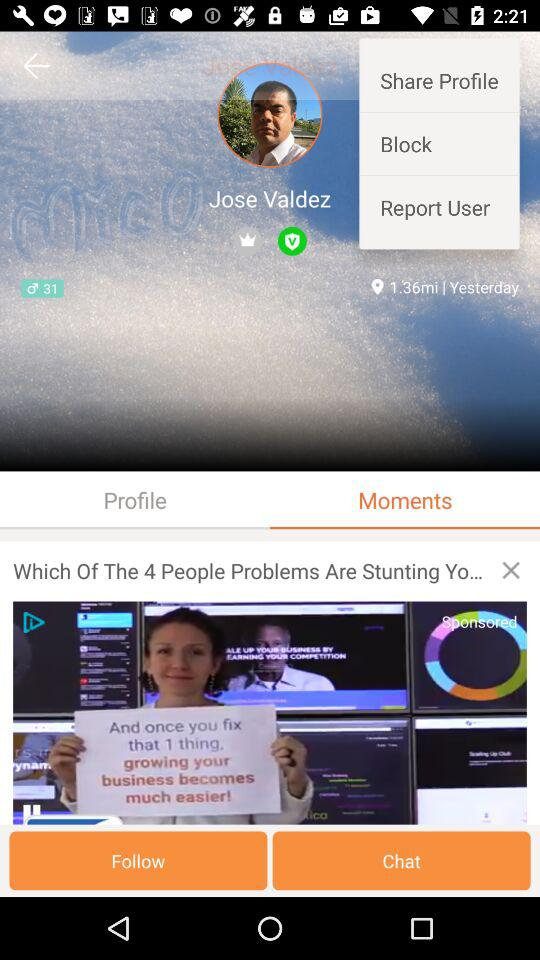What day is shown on the screen?
When the provided information is insufficient, respond with <no answer>. <no answer> 